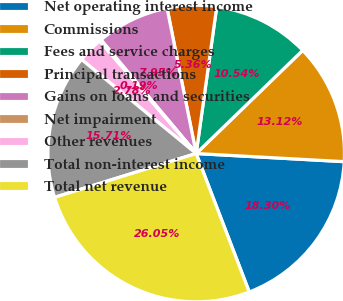Convert chart to OTSL. <chart><loc_0><loc_0><loc_500><loc_500><pie_chart><fcel>Net operating interest income<fcel>Commissions<fcel>Fees and service charges<fcel>Principal transactions<fcel>Gains on loans and securities<fcel>Net impairment<fcel>Other revenues<fcel>Total non-interest income<fcel>Total net revenue<nl><fcel>18.3%<fcel>13.12%<fcel>10.54%<fcel>5.36%<fcel>7.95%<fcel>0.19%<fcel>2.78%<fcel>15.71%<fcel>26.05%<nl></chart> 